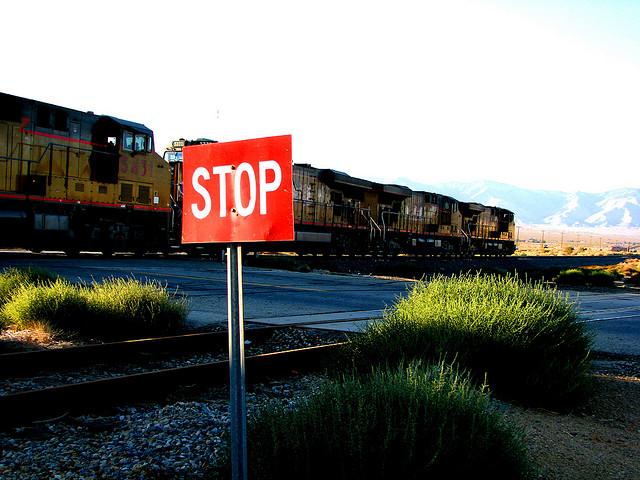Is this a traditional stop sign?
Give a very brief answer. No. Is this a highway?
Keep it brief. No. Is it a sunny day?
Write a very short answer. Yes. What does the sign say?
Write a very short answer. Stop. 